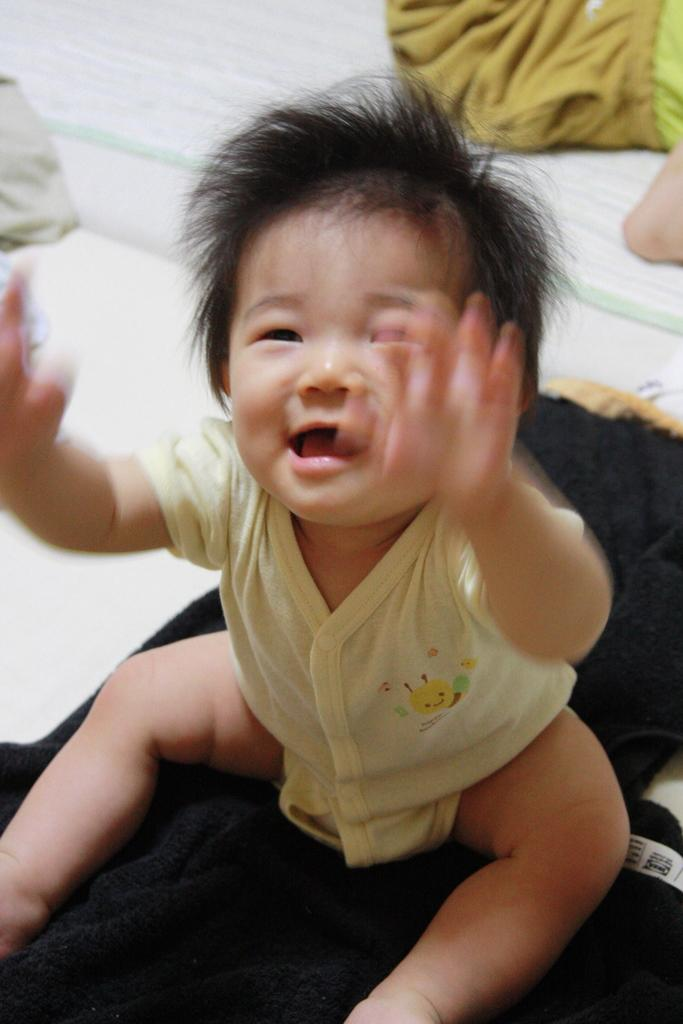What is the main subject of the image? The main subject of the image is a little baby. What type of society is depicted in the image? There is no society depicted in the image; it features a little baby. How many feet can be seen in the image? There is no reference to feet in the image, as it features a little baby. 